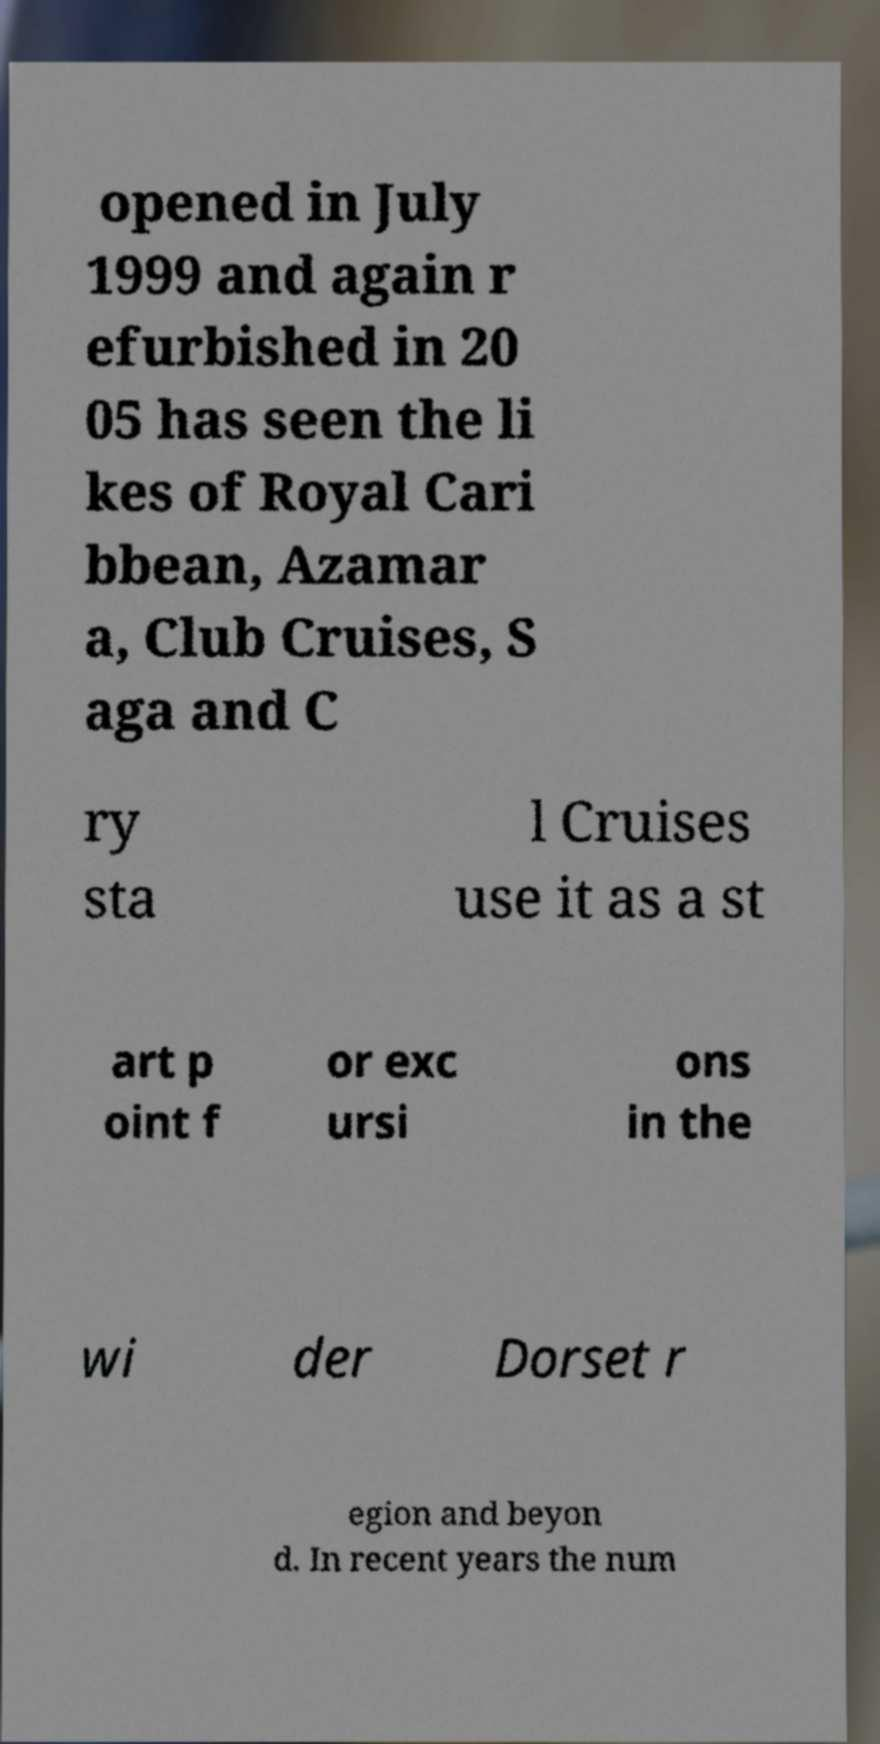Can you accurately transcribe the text from the provided image for me? opened in July 1999 and again r efurbished in 20 05 has seen the li kes of Royal Cari bbean, Azamar a, Club Cruises, S aga and C ry sta l Cruises use it as a st art p oint f or exc ursi ons in the wi der Dorset r egion and beyon d. In recent years the num 